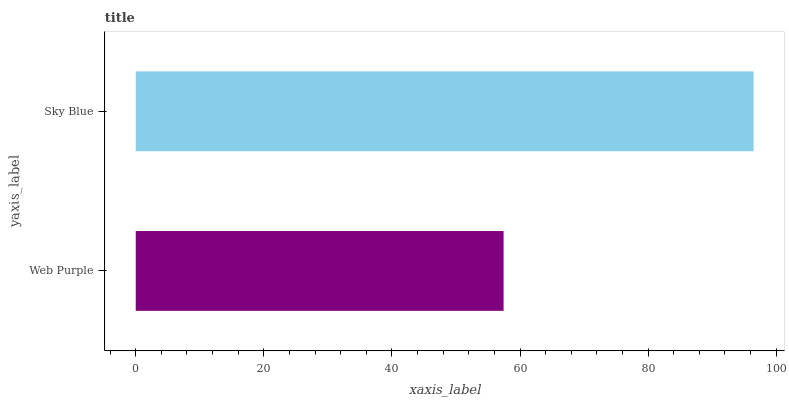Is Web Purple the minimum?
Answer yes or no. Yes. Is Sky Blue the maximum?
Answer yes or no. Yes. Is Sky Blue the minimum?
Answer yes or no. No. Is Sky Blue greater than Web Purple?
Answer yes or no. Yes. Is Web Purple less than Sky Blue?
Answer yes or no. Yes. Is Web Purple greater than Sky Blue?
Answer yes or no. No. Is Sky Blue less than Web Purple?
Answer yes or no. No. Is Sky Blue the high median?
Answer yes or no. Yes. Is Web Purple the low median?
Answer yes or no. Yes. Is Web Purple the high median?
Answer yes or no. No. Is Sky Blue the low median?
Answer yes or no. No. 